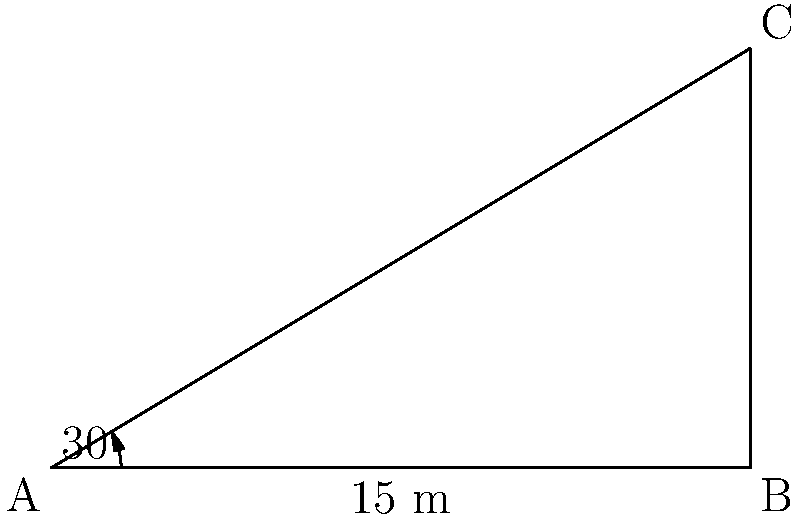A new government office building is being constructed in your district. As a retired district collector with experience in public administration, you're asked to estimate the height of the building using trigonometry. At 3 PM, when the sun's elevation angle is 30°, the building casts a shadow that is 15 meters long. What is the approximate height of the building? Let's approach this step-by-step:

1) In this problem, we have a right-angled triangle where:
   - The shadow length is the base of the triangle (adjacent to the angle)
   - The building height is the opposite side
   - The angle of elevation of the sun is the angle adjacent to the shadow

2) We know:
   - The angle of elevation (θ) = 30°
   - The length of the shadow (adjacent) = 15 meters

3) We need to find the height of the building (opposite side)

4) In a right-angled triangle, tan(θ) = opposite / adjacent

5) Therefore, tan(30°) = height / 15

6) We can rearrange this to: height = 15 * tan(30°)

7) tan(30°) ≈ 0.577

8) So, height ≈ 15 * 0.577 = 8.655 meters

9) Rounding to the nearest tenth: 8.7 meters
Answer: $8.7$ meters 